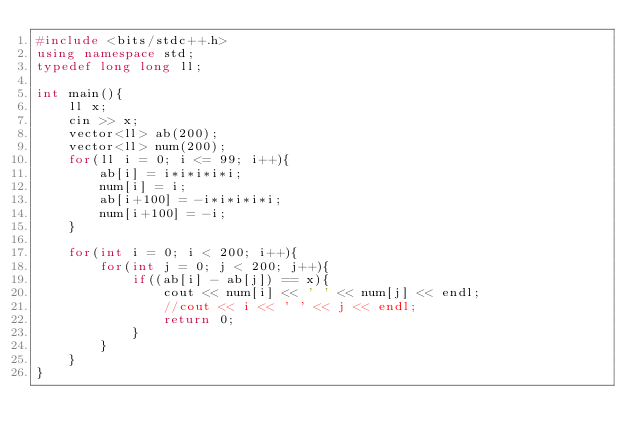<code> <loc_0><loc_0><loc_500><loc_500><_C++_>#include <bits/stdc++.h>
using namespace std;
typedef long long ll;

int main(){
    ll x;
    cin >> x;
    vector<ll> ab(200);
    vector<ll> num(200);
    for(ll i = 0; i <= 99; i++){
        ab[i] = i*i*i*i*i;
        num[i] = i;
        ab[i+100] = -i*i*i*i*i;
        num[i+100] = -i;
    }

    for(int i = 0; i < 200; i++){
        for(int j = 0; j < 200; j++){
            if((ab[i] - ab[j]) == x){
                cout << num[i] << ' ' << num[j] << endl;
                //cout << i << ' ' << j << endl;
                return 0;
            }
        }
    }
}</code> 